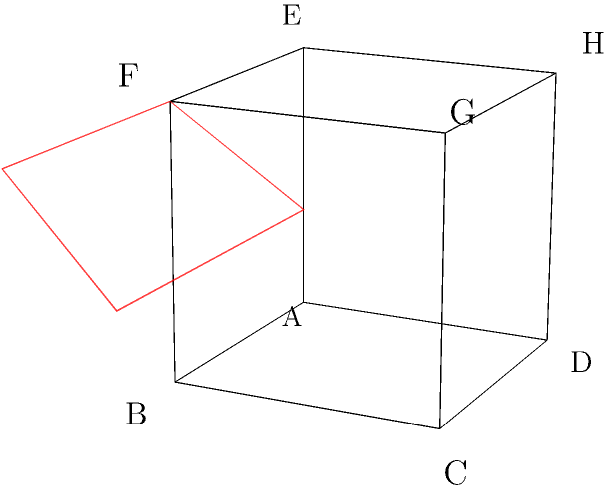As a school principal promoting STEM education, you're demonstrating a 3D visualization exercise to a group of teachers. The image shows a cube ABCDEFGH with two cutting planes: a blue horizontal plane (parallel to base) and a red vertical plane (parallel to face BFGC). What shapes will the cross-sections formed by these planes be? Let's approach this step-by-step:

1. For the blue horizontal plane (parallel to base ABCD):
   - This plane is parallel to the base of the cube.
   - It will intersect all four vertical edges of the cube.
   - The resulting cross-section will be a square, regardless of where the plane intersects the cube.

2. For the red vertical plane (parallel to face BFGC):
   - This plane is parallel to one of the faces of the cube.
   - It will intersect four edges of the cube: BF, CG, AB (or EF), and DC (or HG).
   - The resulting cross-section will be a rectangle.

3. The shape of the rectangle depends on where exactly the plane intersects the cube:
   - If it's exactly in the middle, the rectangle will be a square.
   - If it's closer to one face or the other, it will be a non-square rectangle.

4. It's important to note that in both cases, the cross-sections are always parallel to a face of the cube, which is why they maintain their square or rectangular shape.

This exercise demonstrates how 3D objects can be understood by examining their 2D cross-sections, an important concept in geometry and spatial reasoning.
Answer: Square and rectangle 